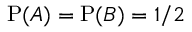Convert formula to latex. <formula><loc_0><loc_0><loc_500><loc_500>P ( A ) = P ( B ) = 1 / 2</formula> 